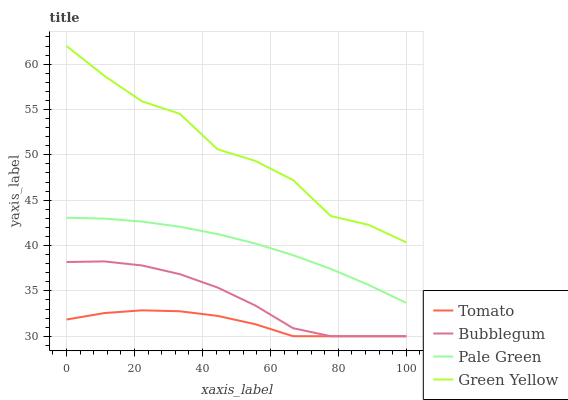Does Tomato have the minimum area under the curve?
Answer yes or no. Yes. Does Green Yellow have the maximum area under the curve?
Answer yes or no. Yes. Does Pale Green have the minimum area under the curve?
Answer yes or no. No. Does Pale Green have the maximum area under the curve?
Answer yes or no. No. Is Pale Green the smoothest?
Answer yes or no. Yes. Is Green Yellow the roughest?
Answer yes or no. Yes. Is Green Yellow the smoothest?
Answer yes or no. No. Is Pale Green the roughest?
Answer yes or no. No. Does Pale Green have the lowest value?
Answer yes or no. No. Does Green Yellow have the highest value?
Answer yes or no. Yes. Does Pale Green have the highest value?
Answer yes or no. No. Is Tomato less than Pale Green?
Answer yes or no. Yes. Is Pale Green greater than Bubblegum?
Answer yes or no. Yes. Does Tomato intersect Pale Green?
Answer yes or no. No. 